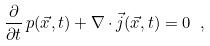<formula> <loc_0><loc_0><loc_500><loc_500>\frac { \partial } { \partial t } \, p ( \vec { x } , t ) + \nabla \cdot \vec { j } ( \vec { x } , t ) = 0 \ ,</formula> 